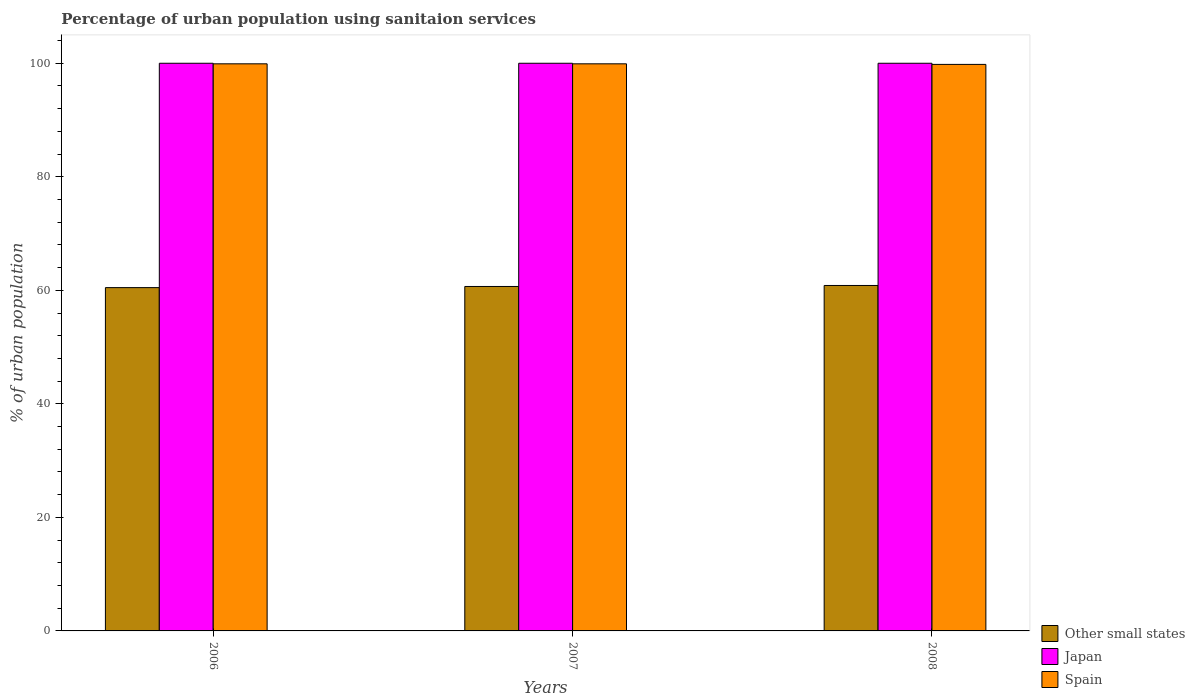How many different coloured bars are there?
Give a very brief answer. 3. How many groups of bars are there?
Provide a short and direct response. 3. What is the label of the 2nd group of bars from the left?
Provide a succinct answer. 2007. In how many cases, is the number of bars for a given year not equal to the number of legend labels?
Your answer should be very brief. 0. What is the percentage of urban population using sanitaion services in Japan in 2006?
Provide a short and direct response. 100. Across all years, what is the maximum percentage of urban population using sanitaion services in Other small states?
Keep it short and to the point. 60.85. Across all years, what is the minimum percentage of urban population using sanitaion services in Other small states?
Offer a terse response. 60.48. In which year was the percentage of urban population using sanitaion services in Spain minimum?
Make the answer very short. 2008. What is the total percentage of urban population using sanitaion services in Japan in the graph?
Keep it short and to the point. 300. What is the difference between the percentage of urban population using sanitaion services in Spain in 2008 and the percentage of urban population using sanitaion services in Other small states in 2007?
Offer a terse response. 39.12. In the year 2007, what is the difference between the percentage of urban population using sanitaion services in Japan and percentage of urban population using sanitaion services in Spain?
Offer a terse response. 0.1. In how many years, is the percentage of urban population using sanitaion services in Japan greater than 100 %?
Your answer should be very brief. 0. What is the ratio of the percentage of urban population using sanitaion services in Other small states in 2007 to that in 2008?
Provide a succinct answer. 1. What is the difference between the highest and the second highest percentage of urban population using sanitaion services in Japan?
Give a very brief answer. 0. What is the difference between the highest and the lowest percentage of urban population using sanitaion services in Spain?
Keep it short and to the point. 0.1. Is the sum of the percentage of urban population using sanitaion services in Spain in 2006 and 2007 greater than the maximum percentage of urban population using sanitaion services in Japan across all years?
Make the answer very short. Yes. What does the 1st bar from the left in 2006 represents?
Provide a short and direct response. Other small states. What does the 1st bar from the right in 2007 represents?
Your answer should be compact. Spain. Is it the case that in every year, the sum of the percentage of urban population using sanitaion services in Spain and percentage of urban population using sanitaion services in Other small states is greater than the percentage of urban population using sanitaion services in Japan?
Give a very brief answer. Yes. How many bars are there?
Your answer should be very brief. 9. Does the graph contain any zero values?
Keep it short and to the point. No. Does the graph contain grids?
Offer a very short reply. No. How many legend labels are there?
Your answer should be very brief. 3. How are the legend labels stacked?
Keep it short and to the point. Vertical. What is the title of the graph?
Offer a very short reply. Percentage of urban population using sanitaion services. Does "Zimbabwe" appear as one of the legend labels in the graph?
Give a very brief answer. No. What is the label or title of the X-axis?
Make the answer very short. Years. What is the label or title of the Y-axis?
Keep it short and to the point. % of urban population. What is the % of urban population in Other small states in 2006?
Offer a very short reply. 60.48. What is the % of urban population in Japan in 2006?
Make the answer very short. 100. What is the % of urban population in Spain in 2006?
Your response must be concise. 99.9. What is the % of urban population of Other small states in 2007?
Make the answer very short. 60.68. What is the % of urban population in Japan in 2007?
Your response must be concise. 100. What is the % of urban population of Spain in 2007?
Your answer should be very brief. 99.9. What is the % of urban population in Other small states in 2008?
Your answer should be very brief. 60.85. What is the % of urban population in Japan in 2008?
Provide a short and direct response. 100. What is the % of urban population in Spain in 2008?
Offer a very short reply. 99.8. Across all years, what is the maximum % of urban population in Other small states?
Offer a terse response. 60.85. Across all years, what is the maximum % of urban population of Japan?
Give a very brief answer. 100. Across all years, what is the maximum % of urban population of Spain?
Keep it short and to the point. 99.9. Across all years, what is the minimum % of urban population in Other small states?
Keep it short and to the point. 60.48. Across all years, what is the minimum % of urban population of Spain?
Provide a succinct answer. 99.8. What is the total % of urban population of Other small states in the graph?
Provide a short and direct response. 182.01. What is the total % of urban population in Japan in the graph?
Offer a very short reply. 300. What is the total % of urban population of Spain in the graph?
Your answer should be very brief. 299.6. What is the difference between the % of urban population of Other small states in 2006 and that in 2007?
Provide a short and direct response. -0.2. What is the difference between the % of urban population of Japan in 2006 and that in 2007?
Offer a very short reply. 0. What is the difference between the % of urban population of Spain in 2006 and that in 2007?
Give a very brief answer. 0. What is the difference between the % of urban population in Other small states in 2006 and that in 2008?
Keep it short and to the point. -0.37. What is the difference between the % of urban population in Japan in 2006 and that in 2008?
Offer a very short reply. 0. What is the difference between the % of urban population in Other small states in 2007 and that in 2008?
Provide a short and direct response. -0.18. What is the difference between the % of urban population of Other small states in 2006 and the % of urban population of Japan in 2007?
Your answer should be compact. -39.52. What is the difference between the % of urban population in Other small states in 2006 and the % of urban population in Spain in 2007?
Your response must be concise. -39.42. What is the difference between the % of urban population of Japan in 2006 and the % of urban population of Spain in 2007?
Your response must be concise. 0.1. What is the difference between the % of urban population in Other small states in 2006 and the % of urban population in Japan in 2008?
Give a very brief answer. -39.52. What is the difference between the % of urban population of Other small states in 2006 and the % of urban population of Spain in 2008?
Offer a very short reply. -39.32. What is the difference between the % of urban population in Other small states in 2007 and the % of urban population in Japan in 2008?
Offer a terse response. -39.32. What is the difference between the % of urban population of Other small states in 2007 and the % of urban population of Spain in 2008?
Your answer should be very brief. -39.12. What is the difference between the % of urban population of Japan in 2007 and the % of urban population of Spain in 2008?
Give a very brief answer. 0.2. What is the average % of urban population of Other small states per year?
Your answer should be compact. 60.67. What is the average % of urban population in Japan per year?
Give a very brief answer. 100. What is the average % of urban population in Spain per year?
Offer a terse response. 99.87. In the year 2006, what is the difference between the % of urban population of Other small states and % of urban population of Japan?
Give a very brief answer. -39.52. In the year 2006, what is the difference between the % of urban population in Other small states and % of urban population in Spain?
Your response must be concise. -39.42. In the year 2006, what is the difference between the % of urban population of Japan and % of urban population of Spain?
Give a very brief answer. 0.1. In the year 2007, what is the difference between the % of urban population of Other small states and % of urban population of Japan?
Your answer should be very brief. -39.32. In the year 2007, what is the difference between the % of urban population in Other small states and % of urban population in Spain?
Give a very brief answer. -39.22. In the year 2008, what is the difference between the % of urban population in Other small states and % of urban population in Japan?
Your answer should be very brief. -39.15. In the year 2008, what is the difference between the % of urban population in Other small states and % of urban population in Spain?
Keep it short and to the point. -38.95. In the year 2008, what is the difference between the % of urban population of Japan and % of urban population of Spain?
Your answer should be compact. 0.2. What is the ratio of the % of urban population in Other small states in 2007 to that in 2008?
Give a very brief answer. 1. What is the ratio of the % of urban population in Spain in 2007 to that in 2008?
Your answer should be compact. 1. What is the difference between the highest and the second highest % of urban population of Other small states?
Offer a very short reply. 0.18. What is the difference between the highest and the second highest % of urban population of Japan?
Your response must be concise. 0. What is the difference between the highest and the lowest % of urban population of Other small states?
Your answer should be compact. 0.37. What is the difference between the highest and the lowest % of urban population in Japan?
Make the answer very short. 0. 